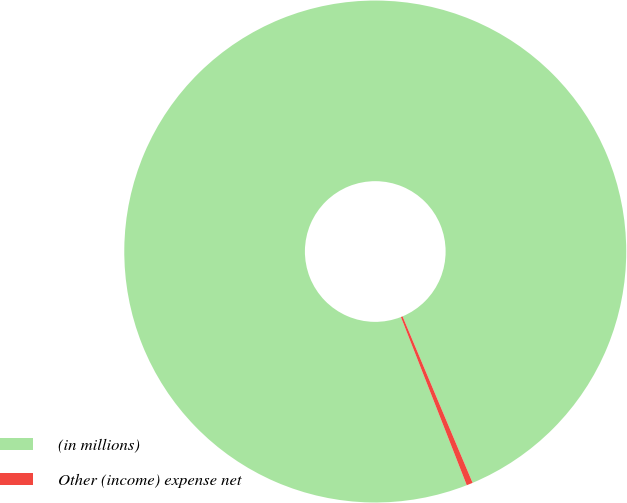Convert chart to OTSL. <chart><loc_0><loc_0><loc_500><loc_500><pie_chart><fcel>(in millions)<fcel>Other (income) expense net<nl><fcel>99.6%<fcel>0.4%<nl></chart> 